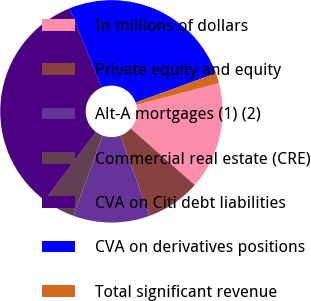Convert chart to OTSL. <chart><loc_0><loc_0><loc_500><loc_500><pie_chart><fcel>In millions of dollars<fcel>Private equity and equity<fcel>Alt-A mortgages (1) (2)<fcel>Commercial real estate (CRE)<fcel>CVA on Citi debt liabilities<fcel>CVA on derivatives positions<fcel>Total significant revenue<nl><fcel>15.61%<fcel>7.9%<fcel>11.12%<fcel>4.68%<fcel>33.62%<fcel>25.59%<fcel>1.47%<nl></chart> 